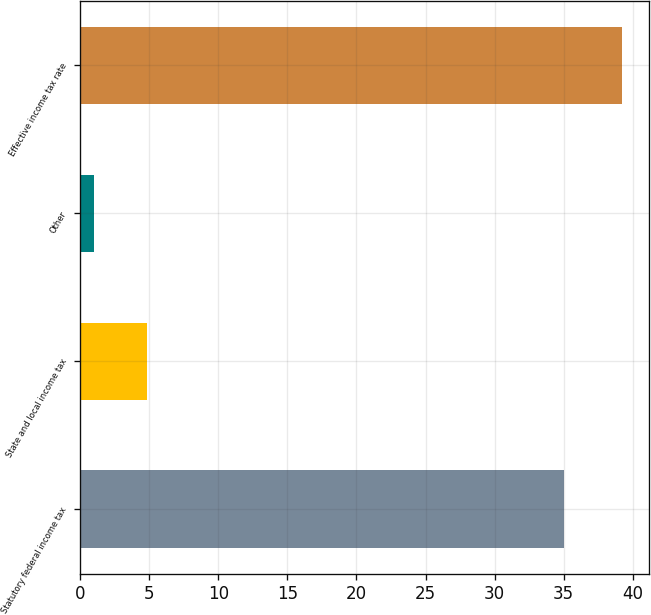Convert chart. <chart><loc_0><loc_0><loc_500><loc_500><bar_chart><fcel>Statutory federal income tax<fcel>State and local income tax<fcel>Other<fcel>Effective income tax rate<nl><fcel>35<fcel>4.82<fcel>1<fcel>39.2<nl></chart> 